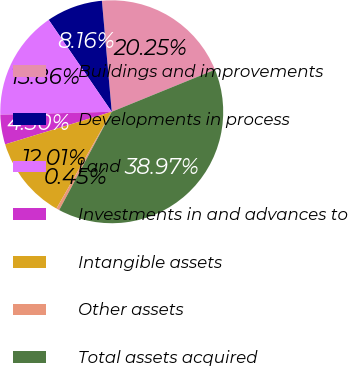Convert chart to OTSL. <chart><loc_0><loc_0><loc_500><loc_500><pie_chart><fcel>Buildings and improvements<fcel>Developments in process<fcel>Land<fcel>Investments in and advances to<fcel>Intangible assets<fcel>Other assets<fcel>Total assets acquired<nl><fcel>20.25%<fcel>8.16%<fcel>15.86%<fcel>4.3%<fcel>12.01%<fcel>0.45%<fcel>38.97%<nl></chart> 